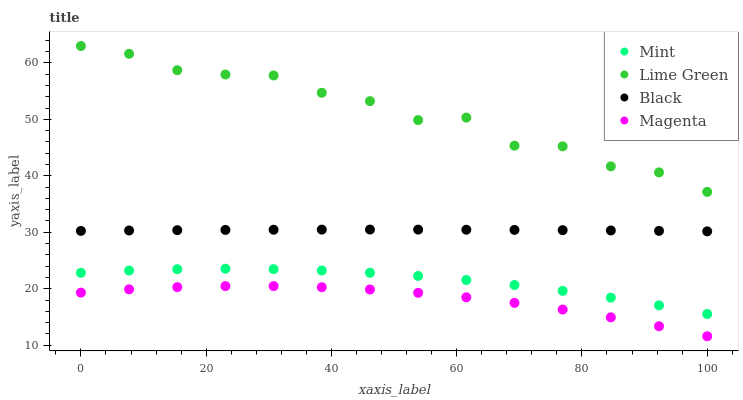Does Magenta have the minimum area under the curve?
Answer yes or no. Yes. Does Lime Green have the maximum area under the curve?
Answer yes or no. Yes. Does Mint have the minimum area under the curve?
Answer yes or no. No. Does Mint have the maximum area under the curve?
Answer yes or no. No. Is Black the smoothest?
Answer yes or no. Yes. Is Lime Green the roughest?
Answer yes or no. Yes. Is Magenta the smoothest?
Answer yes or no. No. Is Magenta the roughest?
Answer yes or no. No. Does Magenta have the lowest value?
Answer yes or no. Yes. Does Mint have the lowest value?
Answer yes or no. No. Does Lime Green have the highest value?
Answer yes or no. Yes. Does Mint have the highest value?
Answer yes or no. No. Is Black less than Lime Green?
Answer yes or no. Yes. Is Mint greater than Magenta?
Answer yes or no. Yes. Does Black intersect Lime Green?
Answer yes or no. No. 